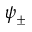Convert formula to latex. <formula><loc_0><loc_0><loc_500><loc_500>\psi _ { \pm }</formula> 